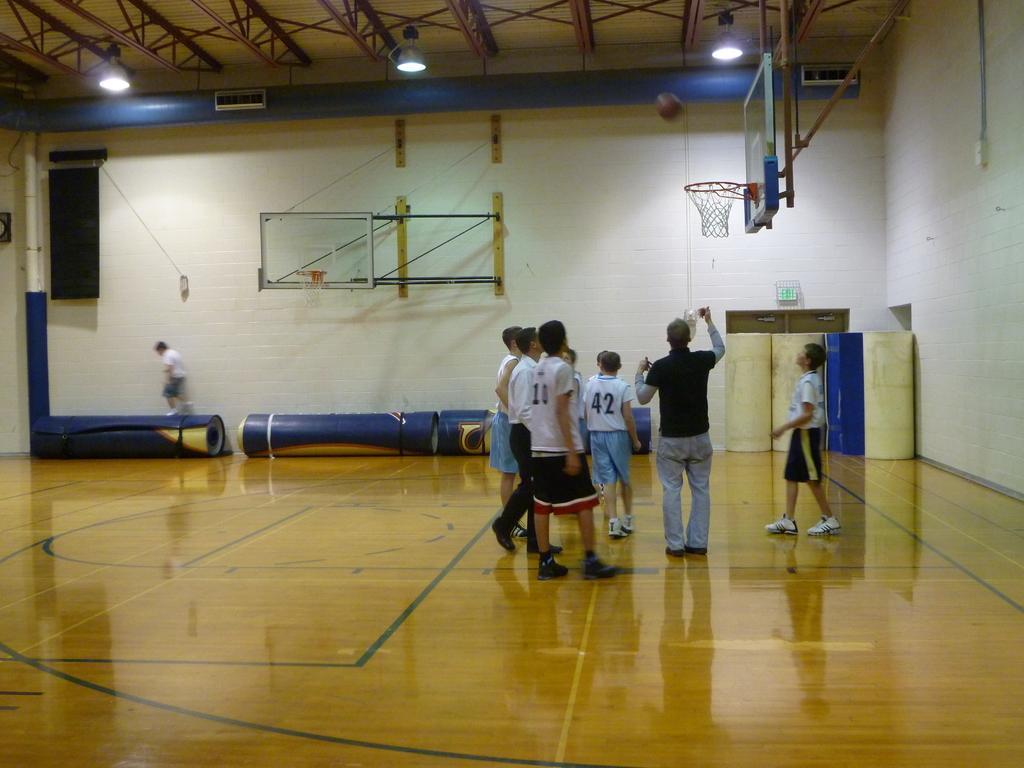Can you describe this image briefly? In this image, we can see people are on the surface. In the background, we can see wall, few objects, person, pole, speaker, sign board and door. Top of the image, we can see pipe, rods, lights and ball in the air. We can see a basketball hoop. 